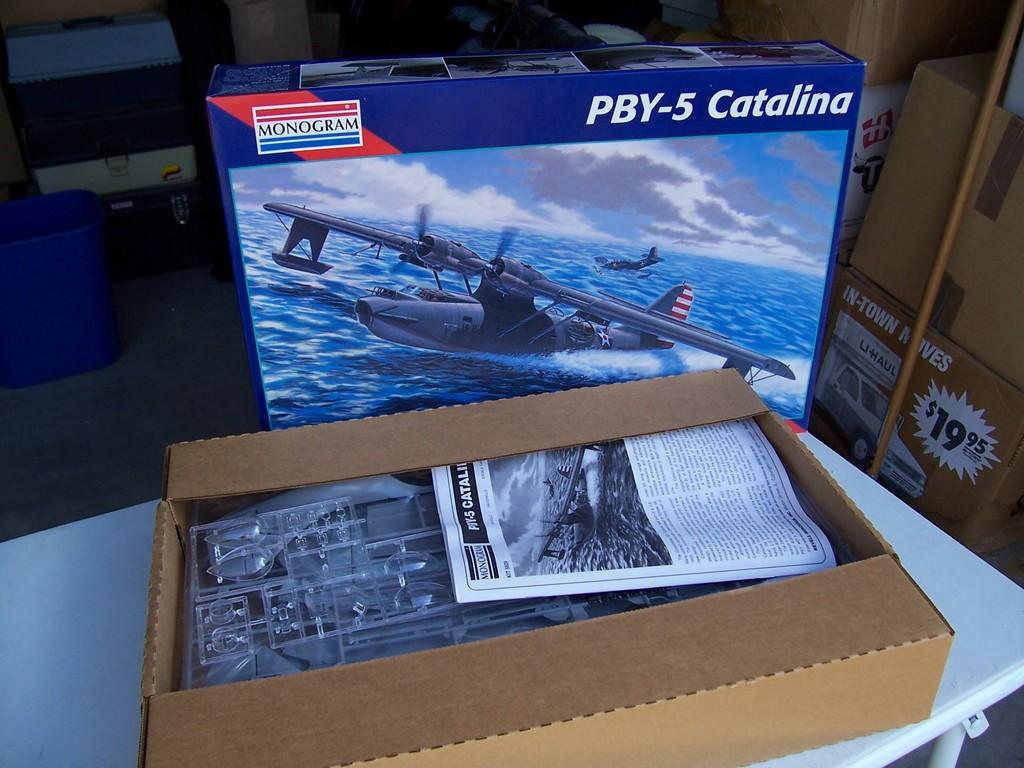<image>
Offer a succinct explanation of the picture presented. a box that says 'pby-5 catalina' on it 